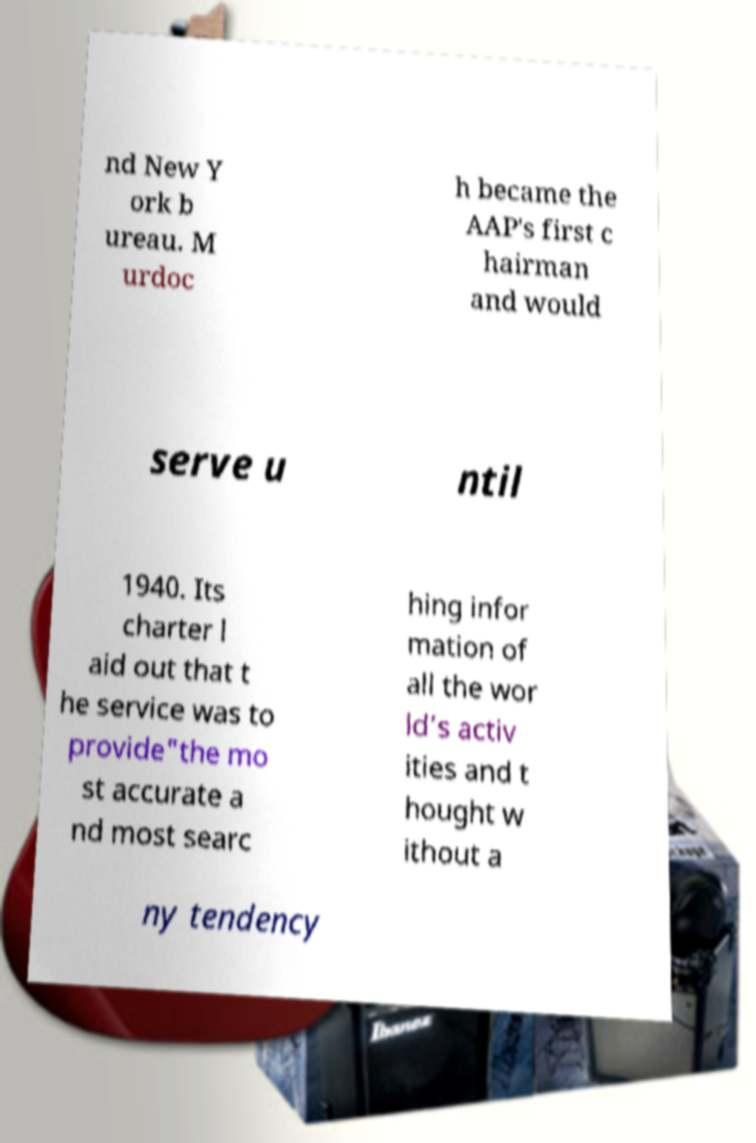I need the written content from this picture converted into text. Can you do that? nd New Y ork b ureau. M urdoc h became the AAP's first c hairman and would serve u ntil 1940. Its charter l aid out that t he service was to provide"the mo st accurate a nd most searc hing infor mation of all the wor ld’s activ ities and t hought w ithout a ny tendency 